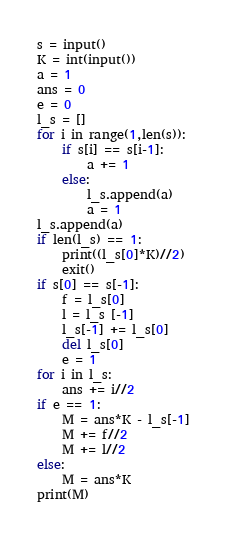Convert code to text. <code><loc_0><loc_0><loc_500><loc_500><_Python_>s = input()
K = int(input())
a = 1
ans = 0
e = 0
l_s = []
for i in range(1,len(s)):
    if s[i] == s[i-1]:
        a += 1
    else:
        l_s.append(a)
        a = 1
l_s.append(a)
if len(l_s) == 1:
    print((l_s[0]*K)//2)
    exit()
if s[0] == s[-1]:
    f = l_s[0]
    l = l_s [-1]
    l_s[-1] += l_s[0]
    del l_s[0]
    e = 1
for i in l_s:
    ans += i//2
if e == 1:
    M = ans*K - l_s[-1]
    M += f//2
    M += l//2
else:
    M = ans*K
print(M)</code> 